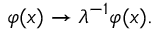<formula> <loc_0><loc_0><loc_500><loc_500>\varphi ( x ) \rightarrow \lambda ^ { - 1 } \varphi ( x ) .</formula> 